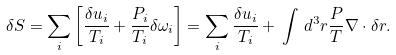<formula> <loc_0><loc_0><loc_500><loc_500>\delta S = \sum _ { i } \left [ \frac { \delta u _ { i } } { T _ { i } } + \frac { P _ { i } } { T _ { i } } \delta \omega _ { i } \right ] = \sum _ { i } \frac { \delta u _ { i } } { T _ { i } } + \, \int \, d ^ { 3 } { r } \frac { P } { T } { \nabla } \cdot \delta { r } .</formula> 